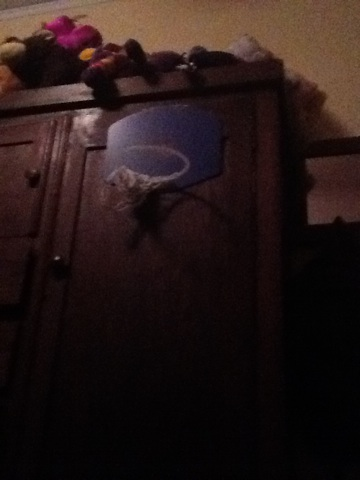What is that? The object in the image is a makeshift basketball hoop attached to a dark wooden cabinet, likely fashioned out of everyday items to offer a playful activity in an indoor setting. The hoop seems to be crafted from a blue basket, creatively repurposed, adding a touch of homemade ingenuity to the room. 